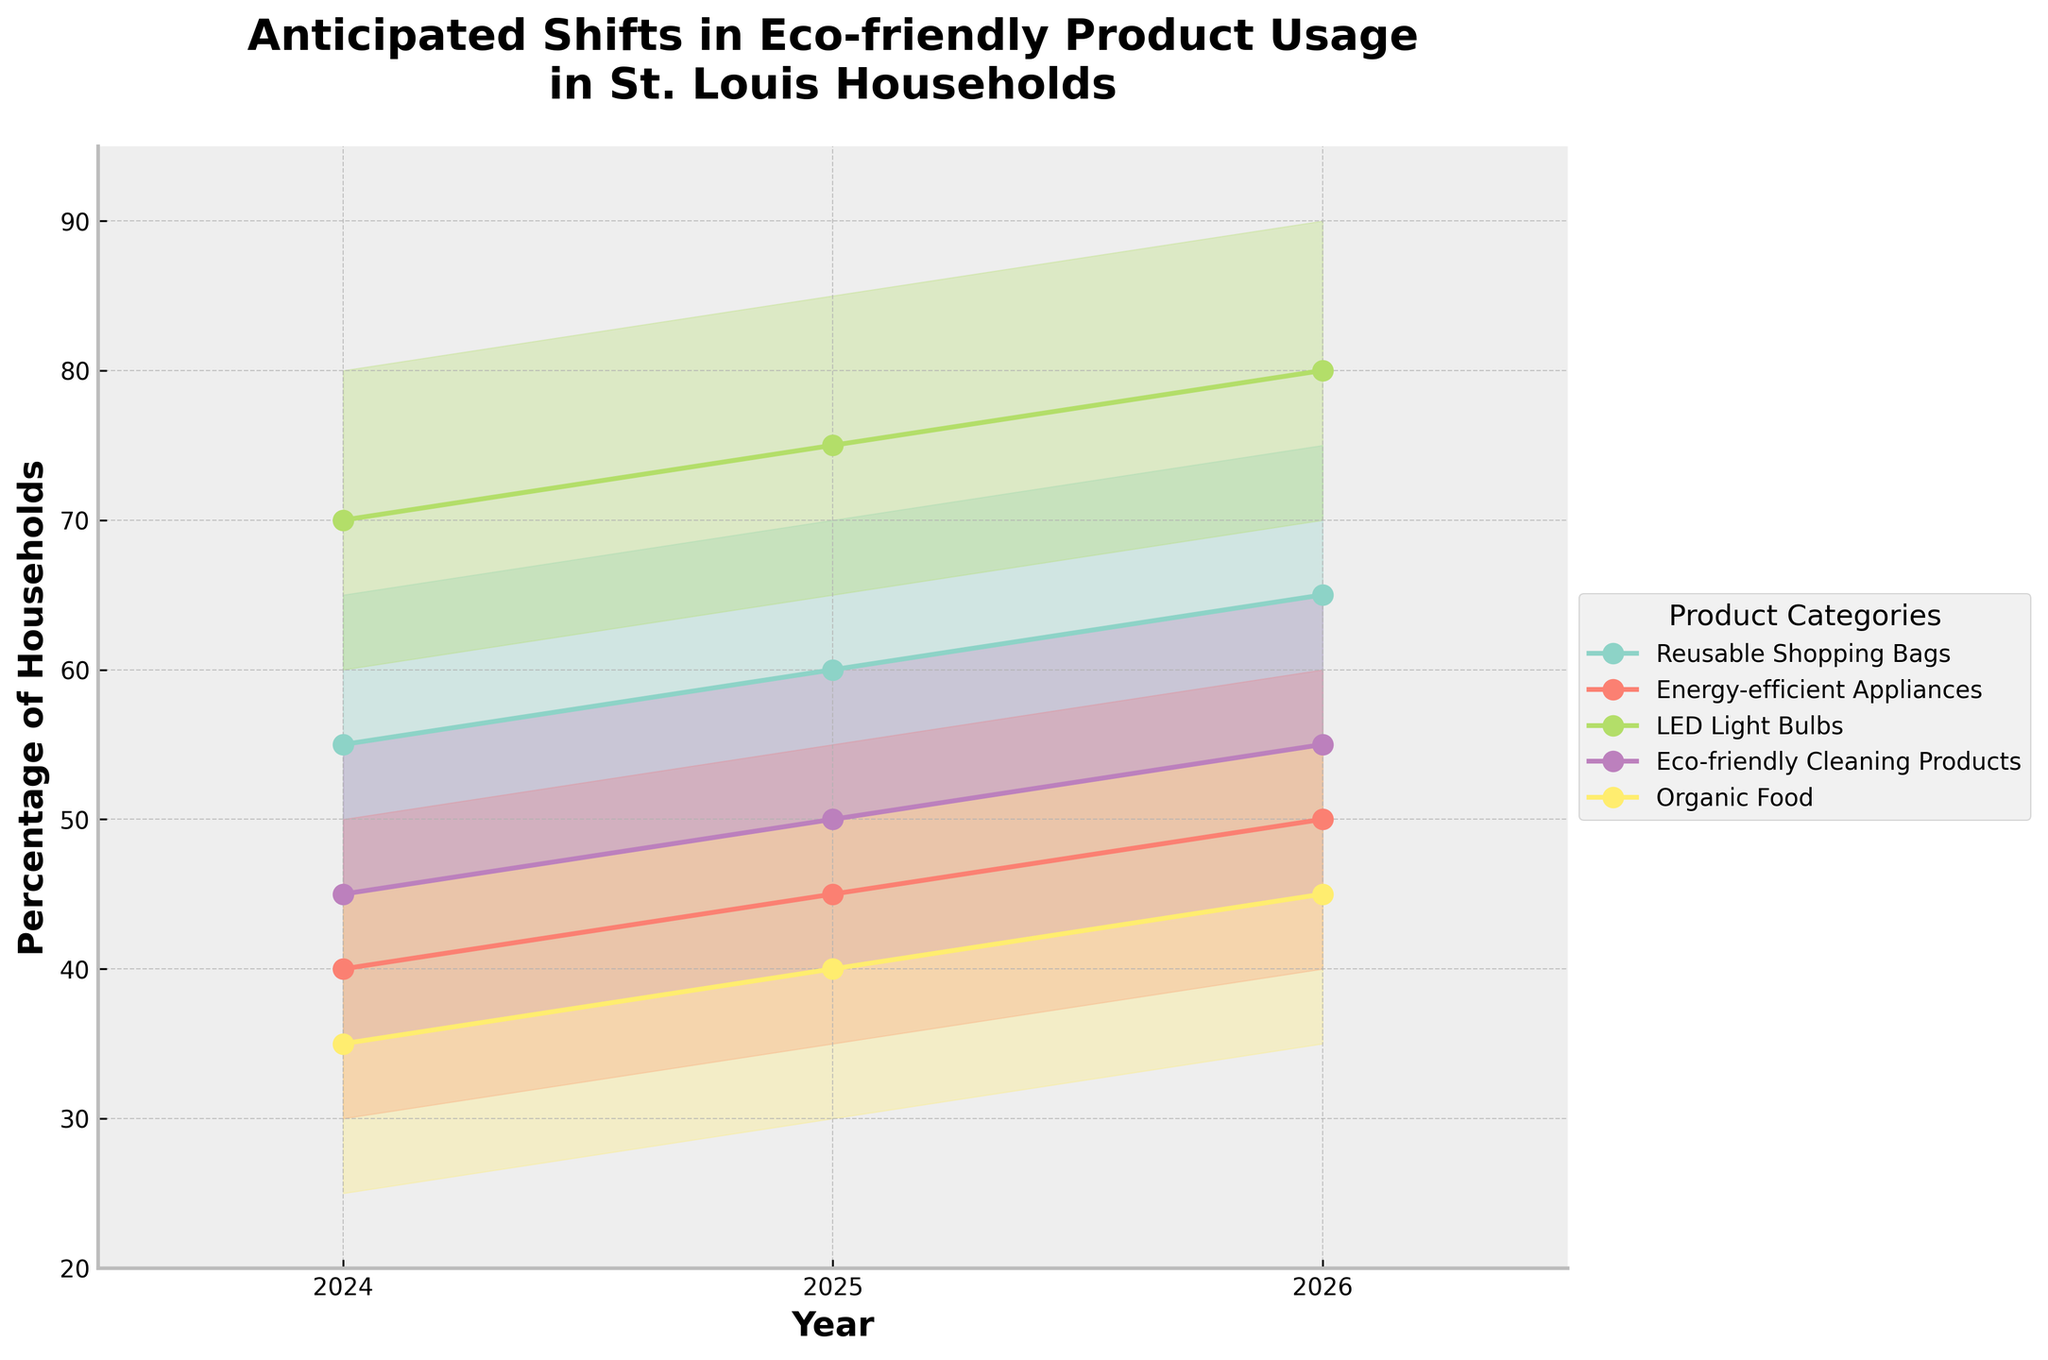Which product category is expected to have the highest usage in 2026? To find the product category with the highest usage in 2026, look at the {'Medium Estimate'} for each category in that year. The highest value is for 'LED Light Bulbs' at 80%.
Answer: LED Light Bulbs What is the difference between the high estimate and low estimate for eco-friendly cleaning products in 2025? For 2025, find the high estimate (60%) and low estimate (40%) for eco-friendly cleaning products. The difference is 60 - 40 = 20%.
Answer: 20% Which product shows a continuous increase in medium estimate usage from 2024 to 2026? Check the medium estimates for each product category over the years 2024, 2025, and 2026. Only 'Reusable Shopping Bags' (55, 60, 65) and 'LED Light Bulbs' (70, 75, 80) show continuous increase.
Answer: Reusable Shopping Bags and LED Light Bulbs What is the anticipated medium estimate usage for organic food in 2025? Find the medium estimate for organic food for the year 2025, which is 40%.
Answer: 40% How does the range of medium estimates for energy-efficient appliances change from 2024 to 2025? Calculate the range for energy-efficient appliances for 2024 (50 - 30 = 20) and 2025 (55 - 35 = 20). The range remains the same at 20%.
Answer: It remains the same Which year shows the highest estimated increase in medium usage for reusable shopping bags? Check the medium values for reusable shopping bags (55 in 2024, 60 in 2025, 65 in 2026). The highest estimated increase is 2025 to 2026: 65-60 = 5%.
Answer: 2025-2026 Which product category is expected to reach at least 85% of households by 2026? Review the high estimates for all product categories in 2026. Only 'LED Light Bulbs' has a high estimate that reaches 90%, meeting the criterion.
Answer: LED Light Bulbs By how much is the usage of energy-efficient appliances expected to grow between 2024 and 2026 in the medium estimate? Check the medium estimates for energy-efficient appliances in 2024 (40%) and 2026 (50%). The growth is 50 - 40 = 10%.
Answer: 10% What is the overall trend for eco-friendly cleaning products over the years covered? Review the medium estimates for eco-friendly cleaning products from 2024 (45%), 2025 (50%), and 2026 (55%). There is a consistent upward trend.
Answer: Upward trend Which product category has the smallest expected growth range in medium estimates between 2024 and 2026? Compare the growth in medium estimates for all product categories between 2024 and 2026. 'Organic Food' grows from 35% to 45%, a range of 10%. This is the smallest range.
Answer: Organic Food 